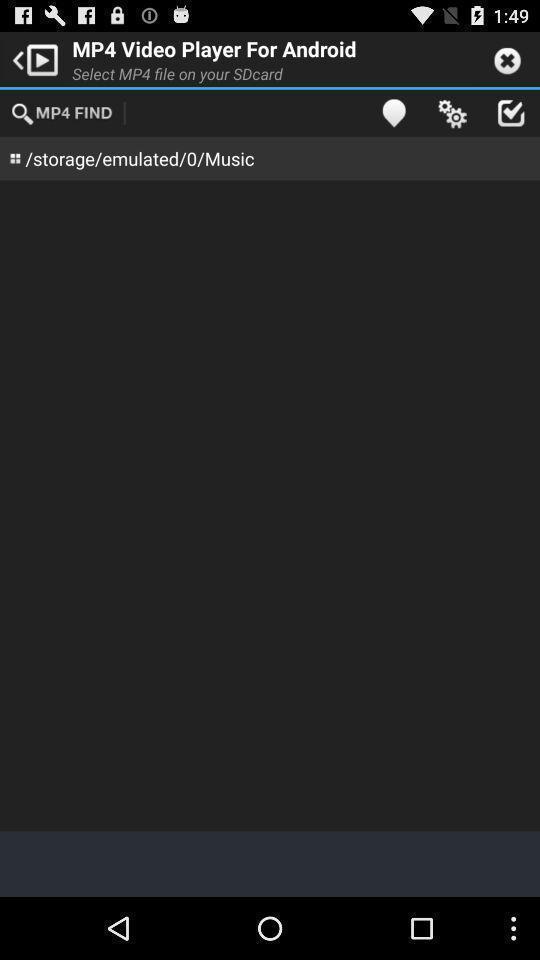Provide a detailed account of this screenshot. Search page for searching videos. 